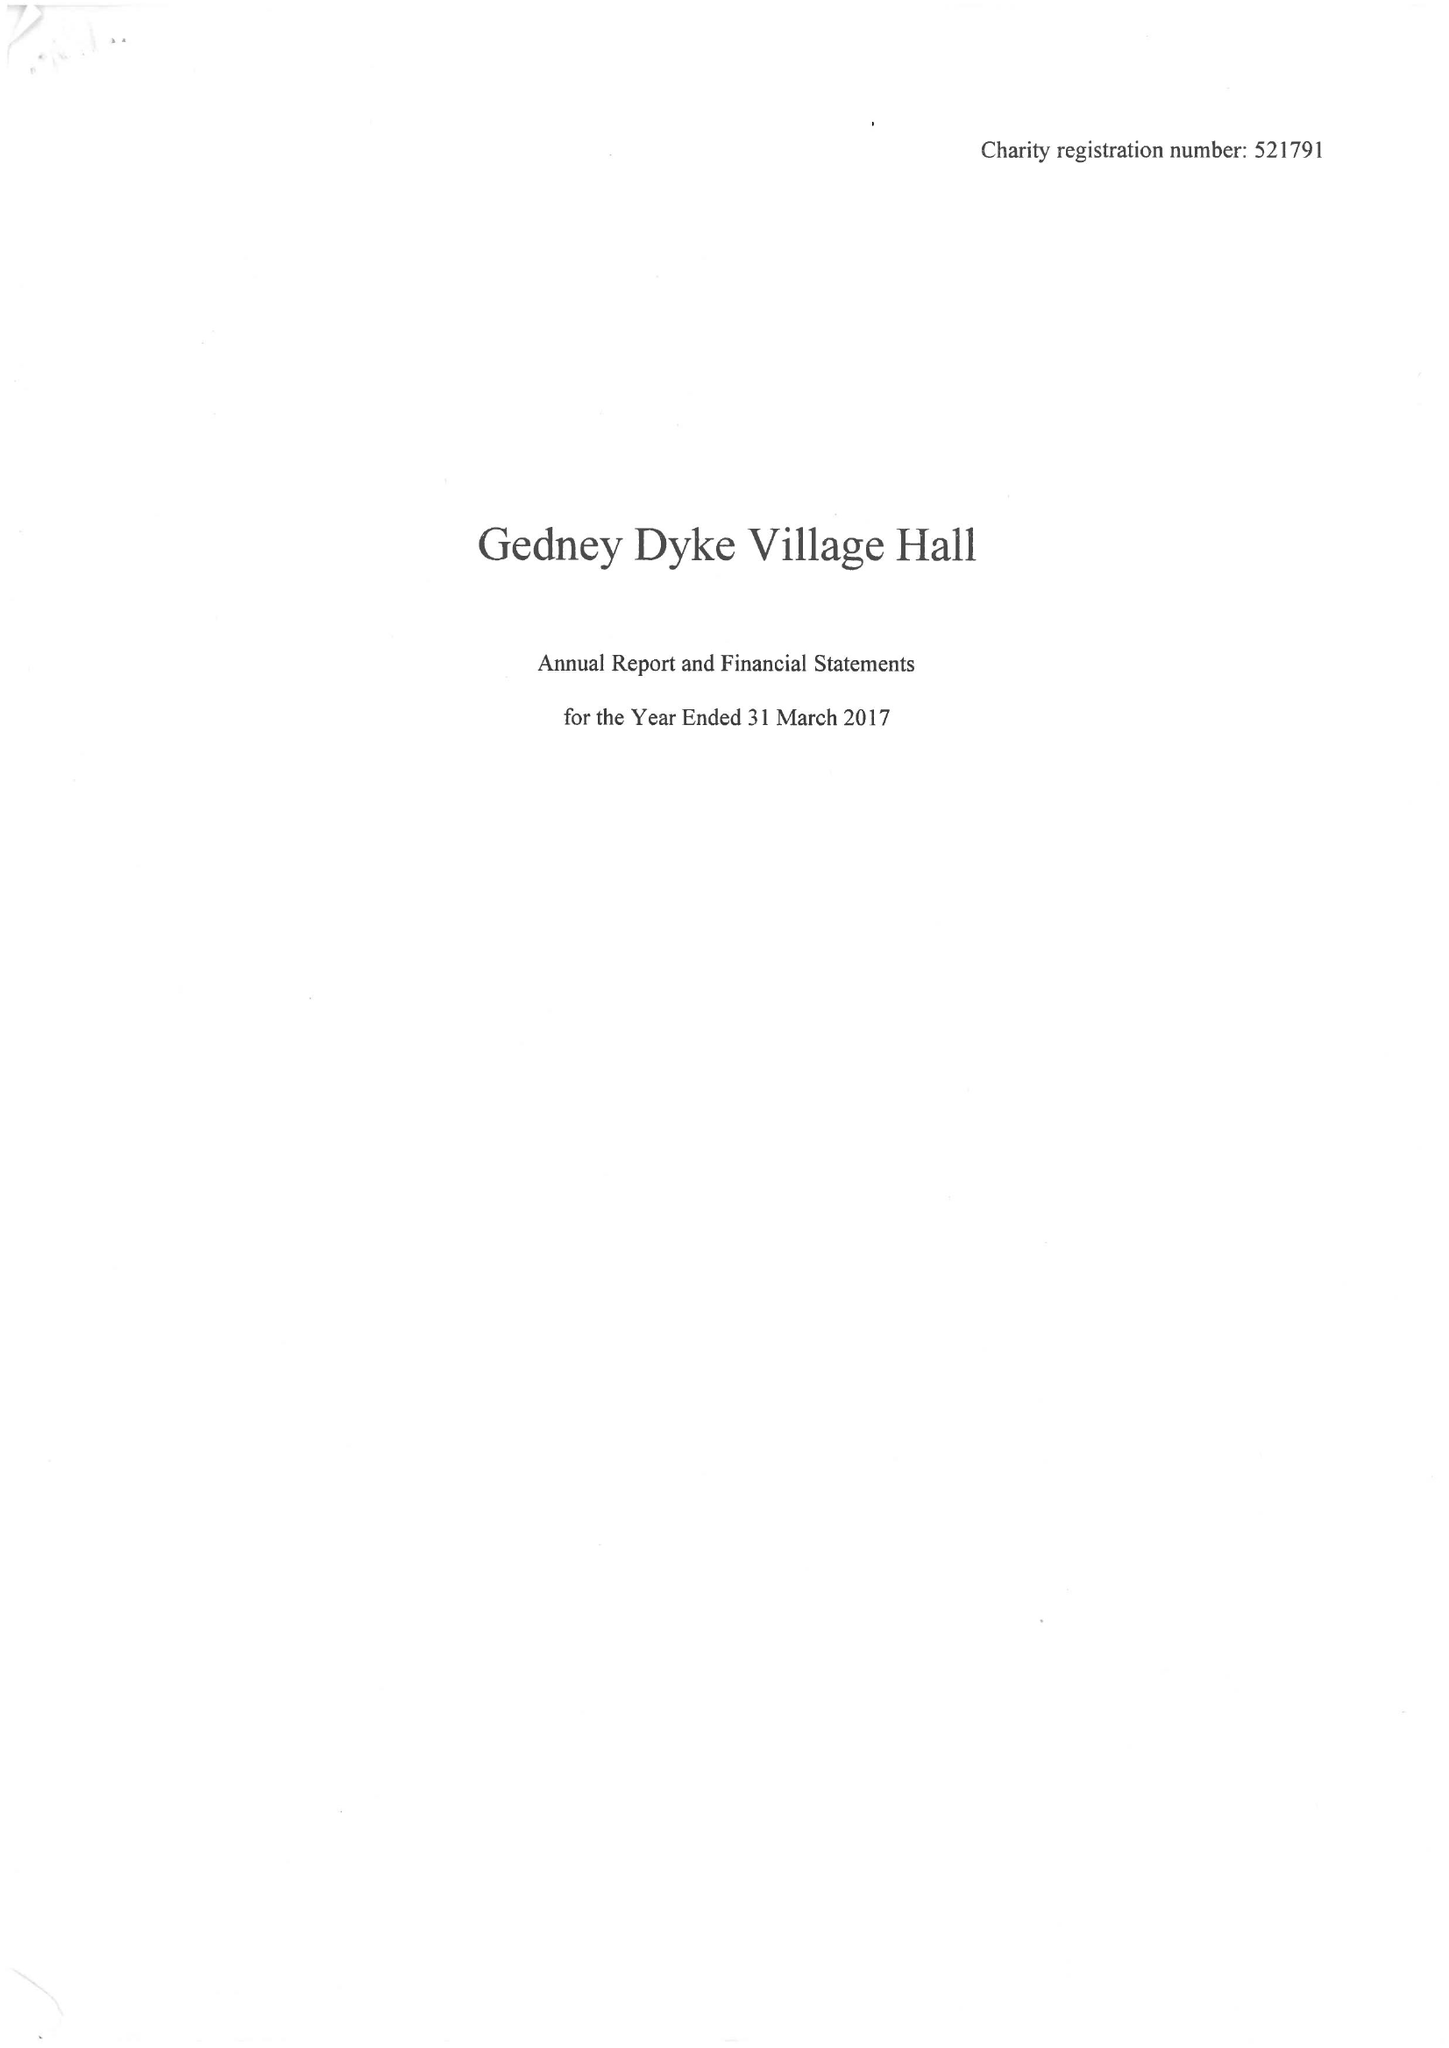What is the value for the report_date?
Answer the question using a single word or phrase. 2017-03-31 